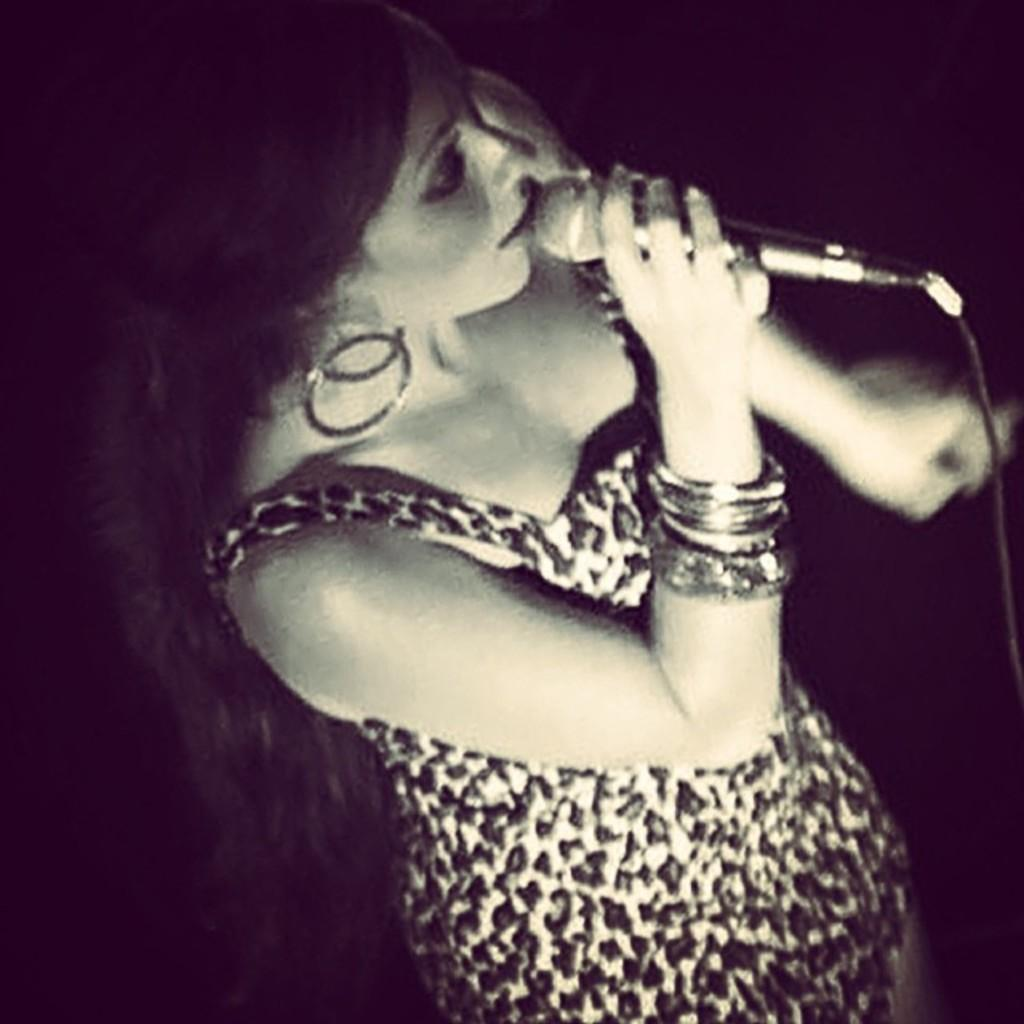What is the woman in the image doing? The woman is standing and singing in the image. What is the woman holding in her hand? The woman is holding a microphone with a wire. What can be observed about the background of the image? The background of the image is dark. What type of cookware is the woman using to cook in the image? There is no cookware or cooking activity present in the image. What part of the microphone is made of a coil? The wire attached to the microphone is made of a coil, but the microphone itself is not made of a coil. 